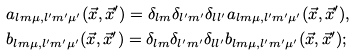Convert formula to latex. <formula><loc_0><loc_0><loc_500><loc_500>& a _ { l m \mu , l ^ { \prime } m ^ { \prime } \mu ^ { \prime } } ( \vec { x } , \vec { x } ^ { \prime } ) = \delta _ { l m } \delta _ { l ^ { \prime } m ^ { \prime } } \delta _ { l l ^ { \prime } } a _ { l m \mu , l ^ { \prime } m ^ { \prime } \mu ^ { \prime } } ( \vec { x } , \vec { x } ^ { \prime } ) , \\ & b _ { l m \mu , l ^ { \prime } m ^ { \prime } \mu ^ { \prime } } ( \vec { x } , \vec { x } ^ { \prime } ) = \delta _ { l m } \delta _ { l ^ { \prime } m ^ { \prime } } \delta _ { l l ^ { \prime } } b _ { l m \mu , l ^ { \prime } m ^ { \prime } \mu ^ { \prime } } ( \vec { x } , \vec { x } ^ { \prime } ) ; \\</formula> 